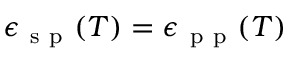Convert formula to latex. <formula><loc_0><loc_0><loc_500><loc_500>\epsilon _ { s p } ( T ) = \epsilon _ { p p } ( T )</formula> 